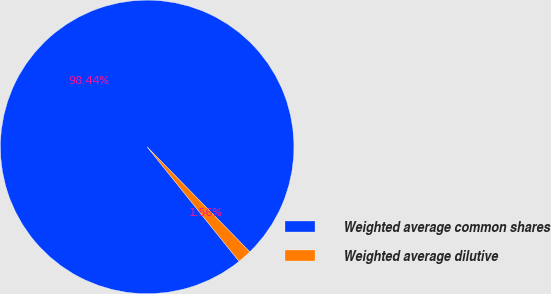Convert chart. <chart><loc_0><loc_0><loc_500><loc_500><pie_chart><fcel>Weighted average common shares<fcel>Weighted average dilutive<nl><fcel>98.44%<fcel>1.56%<nl></chart> 